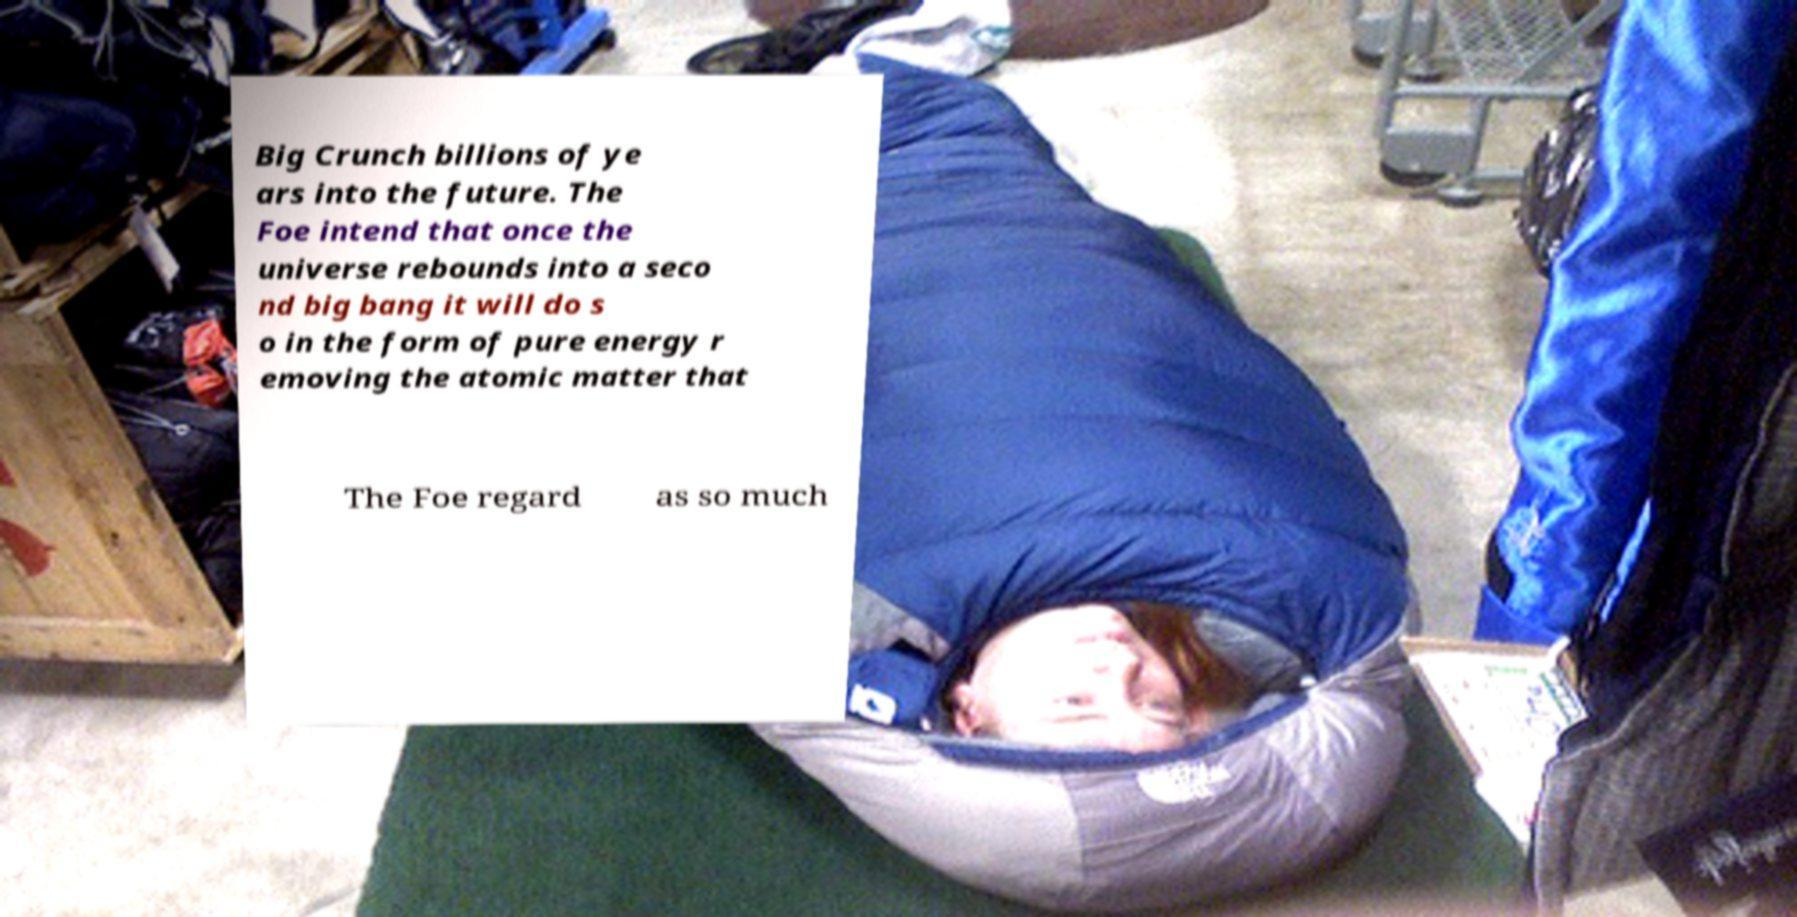Please identify and transcribe the text found in this image. Big Crunch billions of ye ars into the future. The Foe intend that once the universe rebounds into a seco nd big bang it will do s o in the form of pure energy r emoving the atomic matter that The Foe regard as so much 